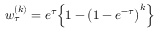<formula> <loc_0><loc_0><loc_500><loc_500>w _ { \tau } ^ { ( k ) } = e ^ { \tau } \left \{ 1 - \left ( 1 - e ^ { - \tau } \right ) ^ { k } \right \}</formula> 